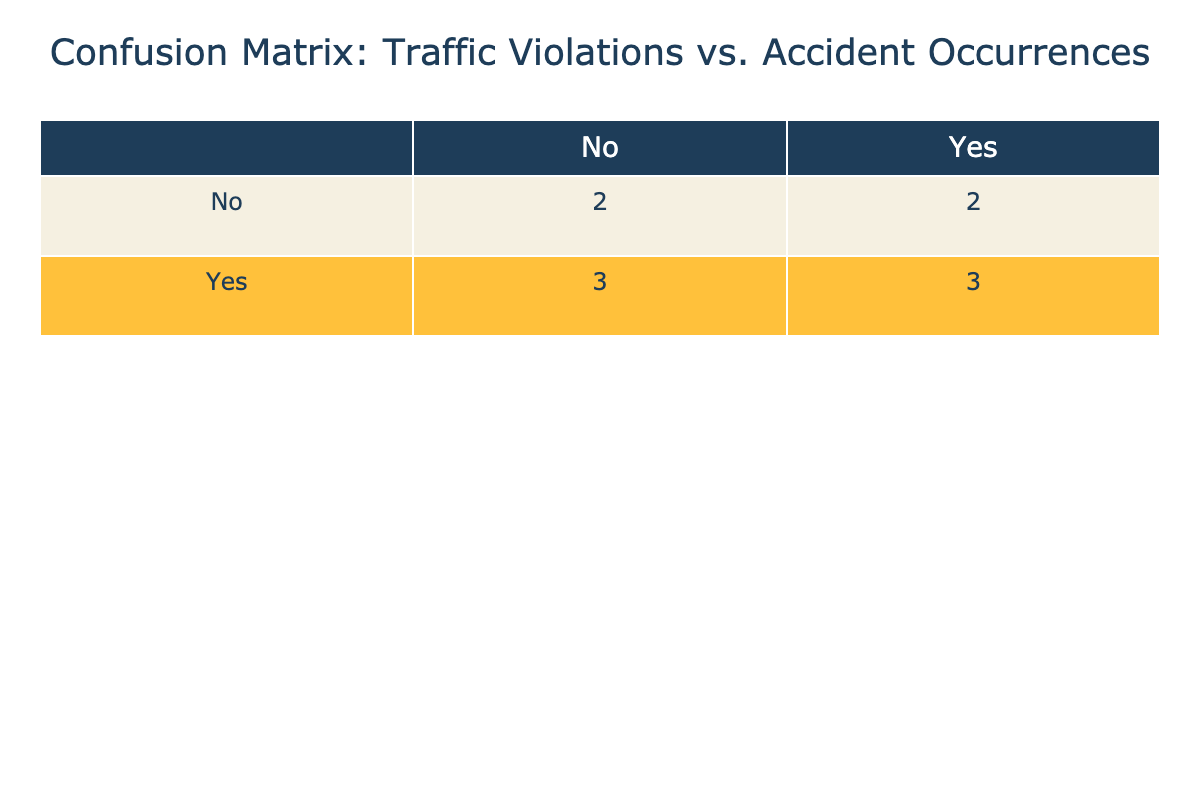What is the total number of instances where there were traffic violations? There are 6 instances of "Yes" in the "Traffic Violations" row in the table. Each "Yes" represents a traffic violation, so we can count them directly from the table.
Answer: 6 What is the total number of instances where accidents occurred without traffic violations? In the table, we see there are 3 instances of "No" under "Traffic Violations" and "Yes" under "Accident Occurrences." This indicates that accidents occurred without traffic violations in three cases.
Answer: 3 Is it true that there were more traffic violations when accidents occurred? Yes, we can see that there are 4 instances where both traffic violations and accidents occurred (as indicated by "Yes" for both categories), and 2 where violations were present but no accidents happened. This indicates that traffic violations often coincide with accidents.
Answer: Yes What is the ratio of traffic violations to accident occurrences in cases where both happened? There are 4 instances of both "Yes" for traffic violations and "Yes" for accident occurrences. To calculate the ratio, we compare the number of traffic violations to the same, which gives us 4:4, simplifying to 1:1.
Answer: 1:1 How many instances had neither traffic violations nor accidents? From the table, we can see that there are 2 instances where both "Traffic Violations" and "Accident Occurrences" are "No". These are the cases where neither event happened at all.
Answer: 2 What percentage of total accident occurrences had traffic violations? To find this percentage, we consider there are 4 accidents with traffic violations (Yes, Yes) and 3 accidents without (No, Yes), hence a total of 7 accidents. The calculation is (4/7) * 100, which gives approximately 57.14%.
Answer: 57.14% How many instances had traffic violations but no accidents? In the table, there are 2 instances where the "Traffic Violations" is "Yes" and the "Accident Occurrences" is "No." This indicates these cases have traffic violations but do not correspond to accidents.
Answer: 2 What can you conclude about the relationship between traffic violations and accidents based on this data? The data shows a notable correlation where most traffic violations coincide with accidents. Specifically, 4 out of 6 instances of traffic violations correlated with accidents. This suggests that when traffic violations occur, they are likely to lead to accidents, but additional analysis would be needed for a definitive conclusion.
Answer: Traffic violations are likely linked to higher accident occurrences 